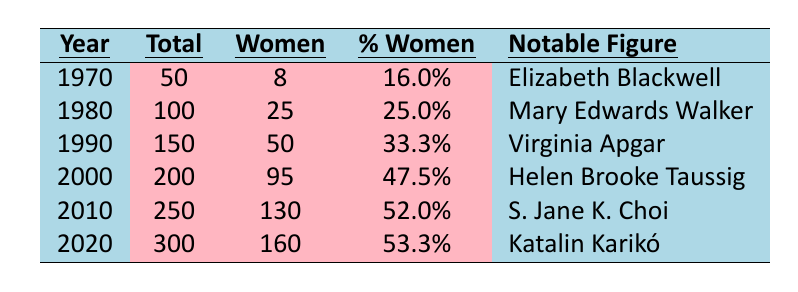What was the total enrollment of medical students in 1970? The table shows the total enrollment for each year, and for 1970, the total enrollment is listed as 50.
Answer: 50 What percentage of medical school enrollments were women in 2000? The table indicates that in 2000, the percentage of women enrolled in medical school was 47.5%.
Answer: 47.5% How many more women enrolled in medical school in 2010 compared to 1980? In 2010, 130 women were enrolled, and in 1980, there were 25. The difference is 130 - 25 = 105.
Answer: 105 What notable figure is associated with the year 1990? According to the table, the notable figure for 1990 is Virginia Apgar.
Answer: Virginia Apgar Was there an increase in the total enrollment of medical students from 1970 to 2020? The total enrollment in 1970 was 50, and in 2020 it increased to 300, confirming that there was indeed an increase.
Answer: Yes What is the average percentage of women enrolled from 1970 to 2020? We sum the percentages from the table: (16 + 25 + 33.3 + 47.5 + 52 + 53.3) = 227.1. Then we divide this sum by the total years, which is 6. The average is 227.1 / 6 ≈ 37.85.
Answer: 37.85 Which year had the highest enrollment of women in medical school? Looking at the women enrollment column, 2000 had the highest number at 95.
Answer: 2000 How many women were enrolled in medical school in 1990 compared to 2010? In 1990, there were 50 women enrolled and in 2010, there were 130. The difference is 130 - 50 = 80 more women in 2010.
Answer: 80 Is it true that the percentage of women enrolled in medical schools increased every decade from 1970 to 2020? Looking at the percentage of women enrolled each decade, we see it rose from 16% in 1970 to 53.3% in 2020, confirming the increase was consistent across decades.
Answer: Yes What notable contributions did Katalin Karikó make, as mentioned in the table? The table states that Katalin Karikó pioneered mRNA vaccine technology.
Answer: Pioneered mRNA vaccine technology What is the total number of women enrolled in all years combined from 1970 to 2020? Adding up the women enrolled gives us 8 + 25 + 50 + 95 + 130 + 160 = 468 women.
Answer: 468 